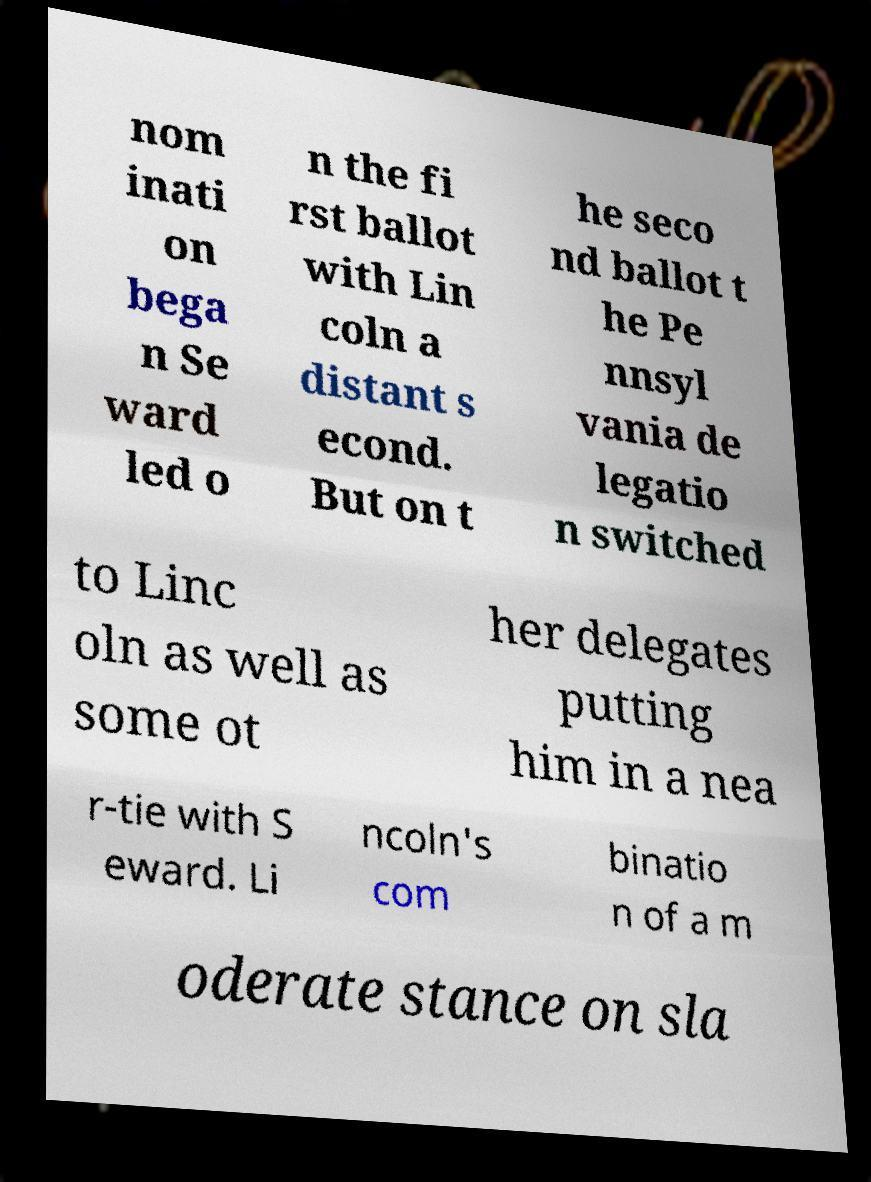Could you assist in decoding the text presented in this image and type it out clearly? nom inati on bega n Se ward led o n the fi rst ballot with Lin coln a distant s econd. But on t he seco nd ballot t he Pe nnsyl vania de legatio n switched to Linc oln as well as some ot her delegates putting him in a nea r-tie with S eward. Li ncoln's com binatio n of a m oderate stance on sla 